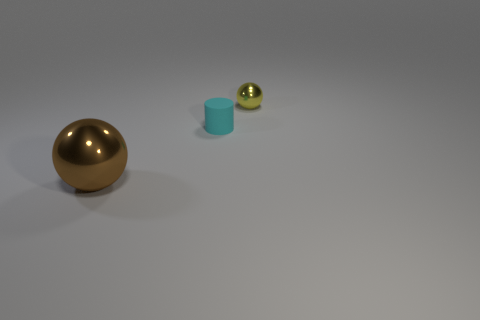What materials do these objects look like they're made of? The objects present distinct textures suggesting that the brown sphere appears to be metallic, probably bronze or gold in color, the blue cylinder looks like a matte plastic, and the small sphere has a glossy surface which could be glass or polished stone. 